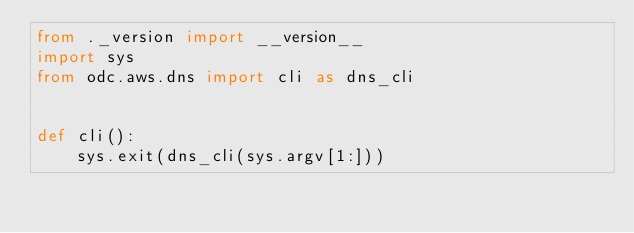<code> <loc_0><loc_0><loc_500><loc_500><_Python_>from ._version import __version__
import sys
from odc.aws.dns import cli as dns_cli


def cli():
    sys.exit(dns_cli(sys.argv[1:]))
</code> 